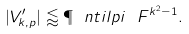<formula> <loc_0><loc_0><loc_500><loc_500>| V ^ { \prime } _ { k , p } | \lessapprox \P \ n t i l p i \ F ^ { k ^ { 2 } - 1 } .</formula> 